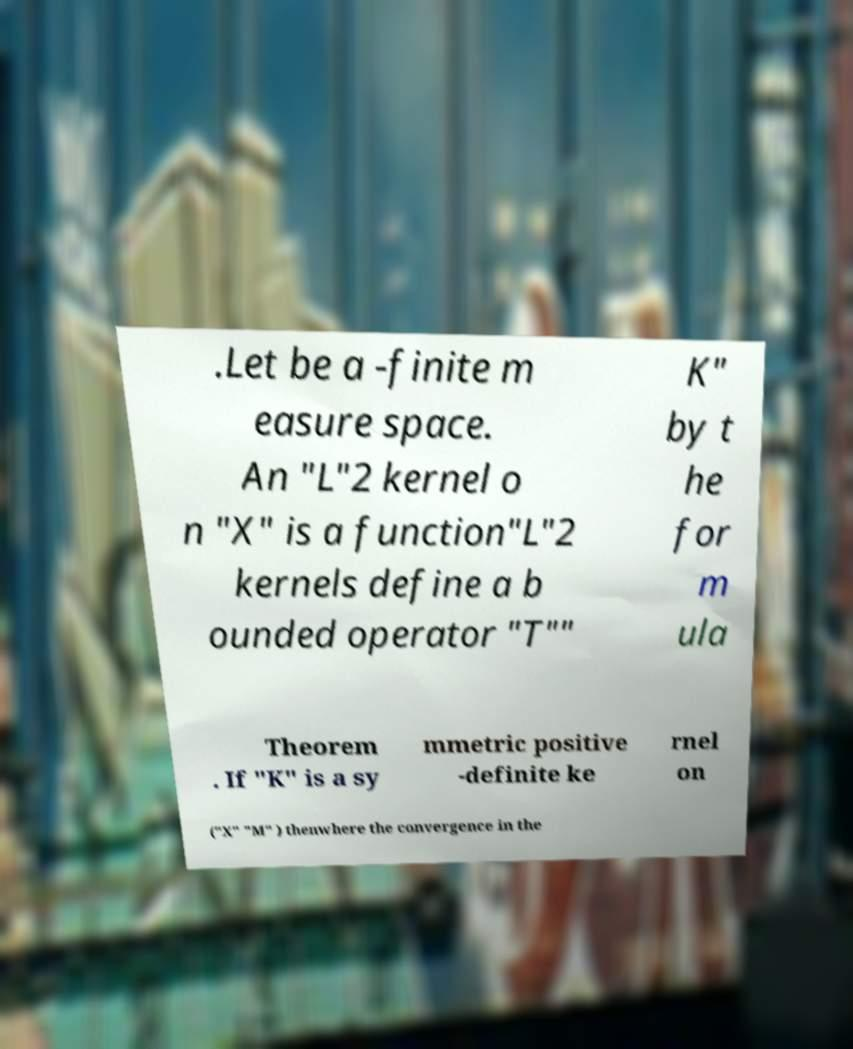There's text embedded in this image that I need extracted. Can you transcribe it verbatim? .Let be a -finite m easure space. An "L"2 kernel o n "X" is a function"L"2 kernels define a b ounded operator "T"" K" by t he for m ula Theorem . If "K" is a sy mmetric positive -definite ke rnel on ("X" "M" ) thenwhere the convergence in the 